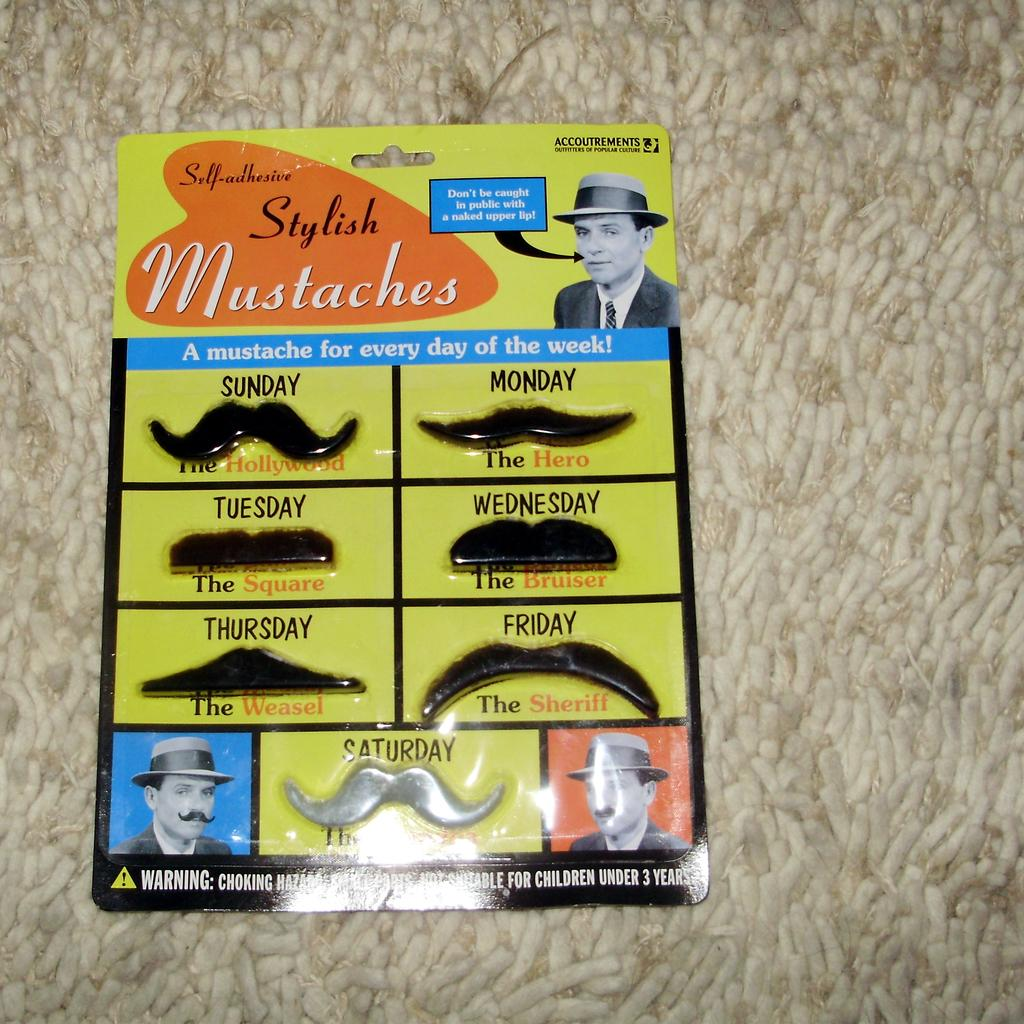What is the main object in the image? There is a card in the image. What is depicted inside the card? There is a man inside the card. Can you describe the man's appearance? The man is wearing a hat and has mustaches. What is the color of the background in the background of the image? The background of the image is white. Is the man holding a gun in the image? No, the man is not holding a gun in the image. Can the card help improve the man's memory? The card does not have any direct impact on the man's memory; it is simply an image of a man with a hat and mustaches. 